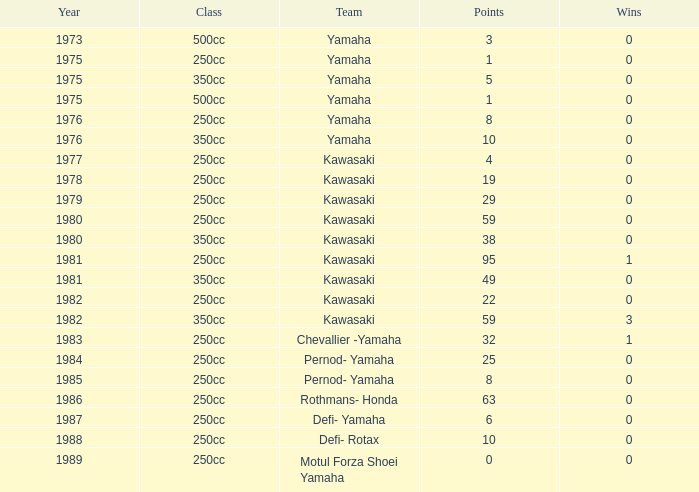How many points numbers had a class of 250cc, a year prior to 1978, Yamaha as a team, and where wins was more than 0? 0.0. 